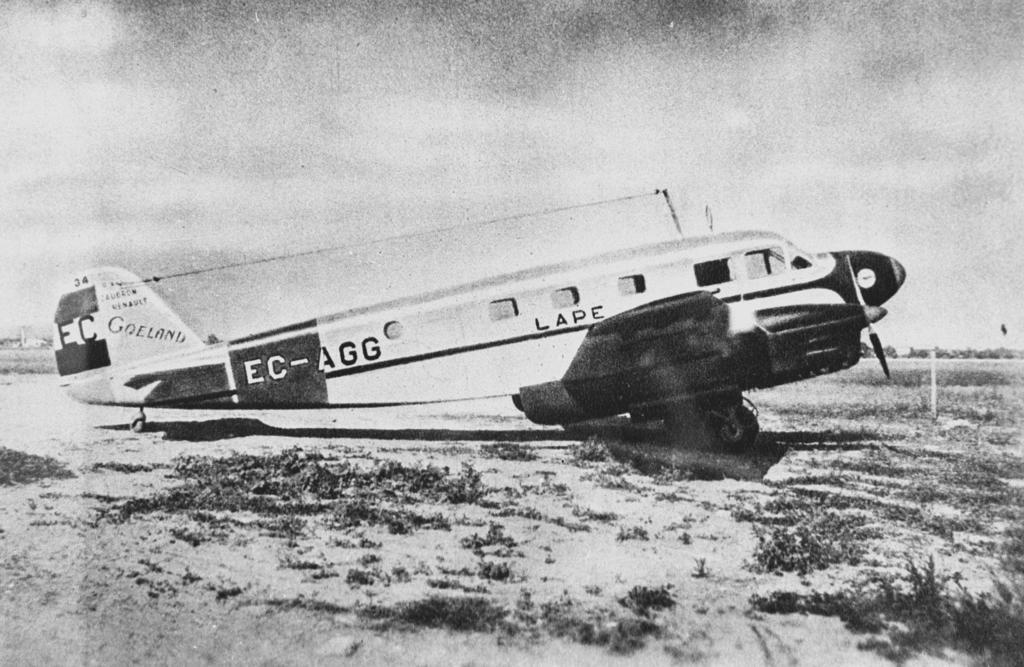<image>
Provide a brief description of the given image. A vintage airplane is marked with several identifiers, including EC-AGG and EC. 